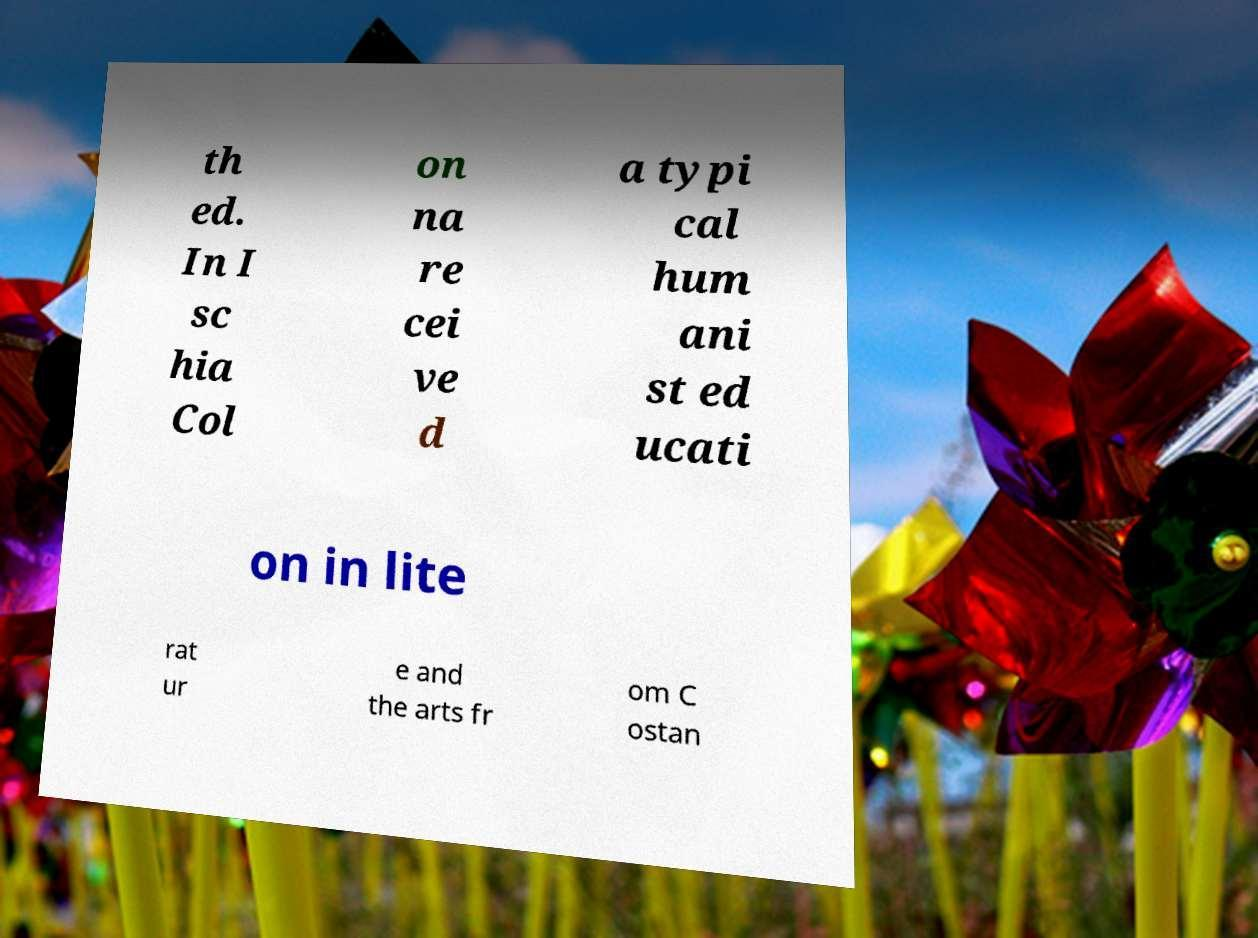Please identify and transcribe the text found in this image. th ed. In I sc hia Col on na re cei ve d a typi cal hum ani st ed ucati on in lite rat ur e and the arts fr om C ostan 